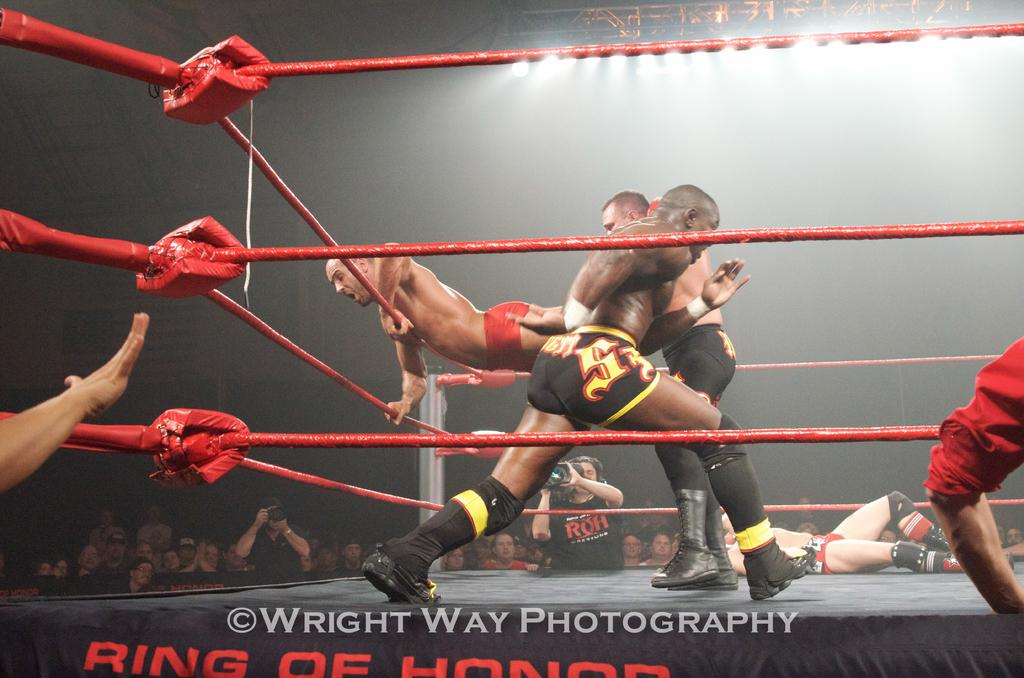<image>
Describe the image concisely. a couple people in a ring getting ready to wrestle with Ring of Honor written below 